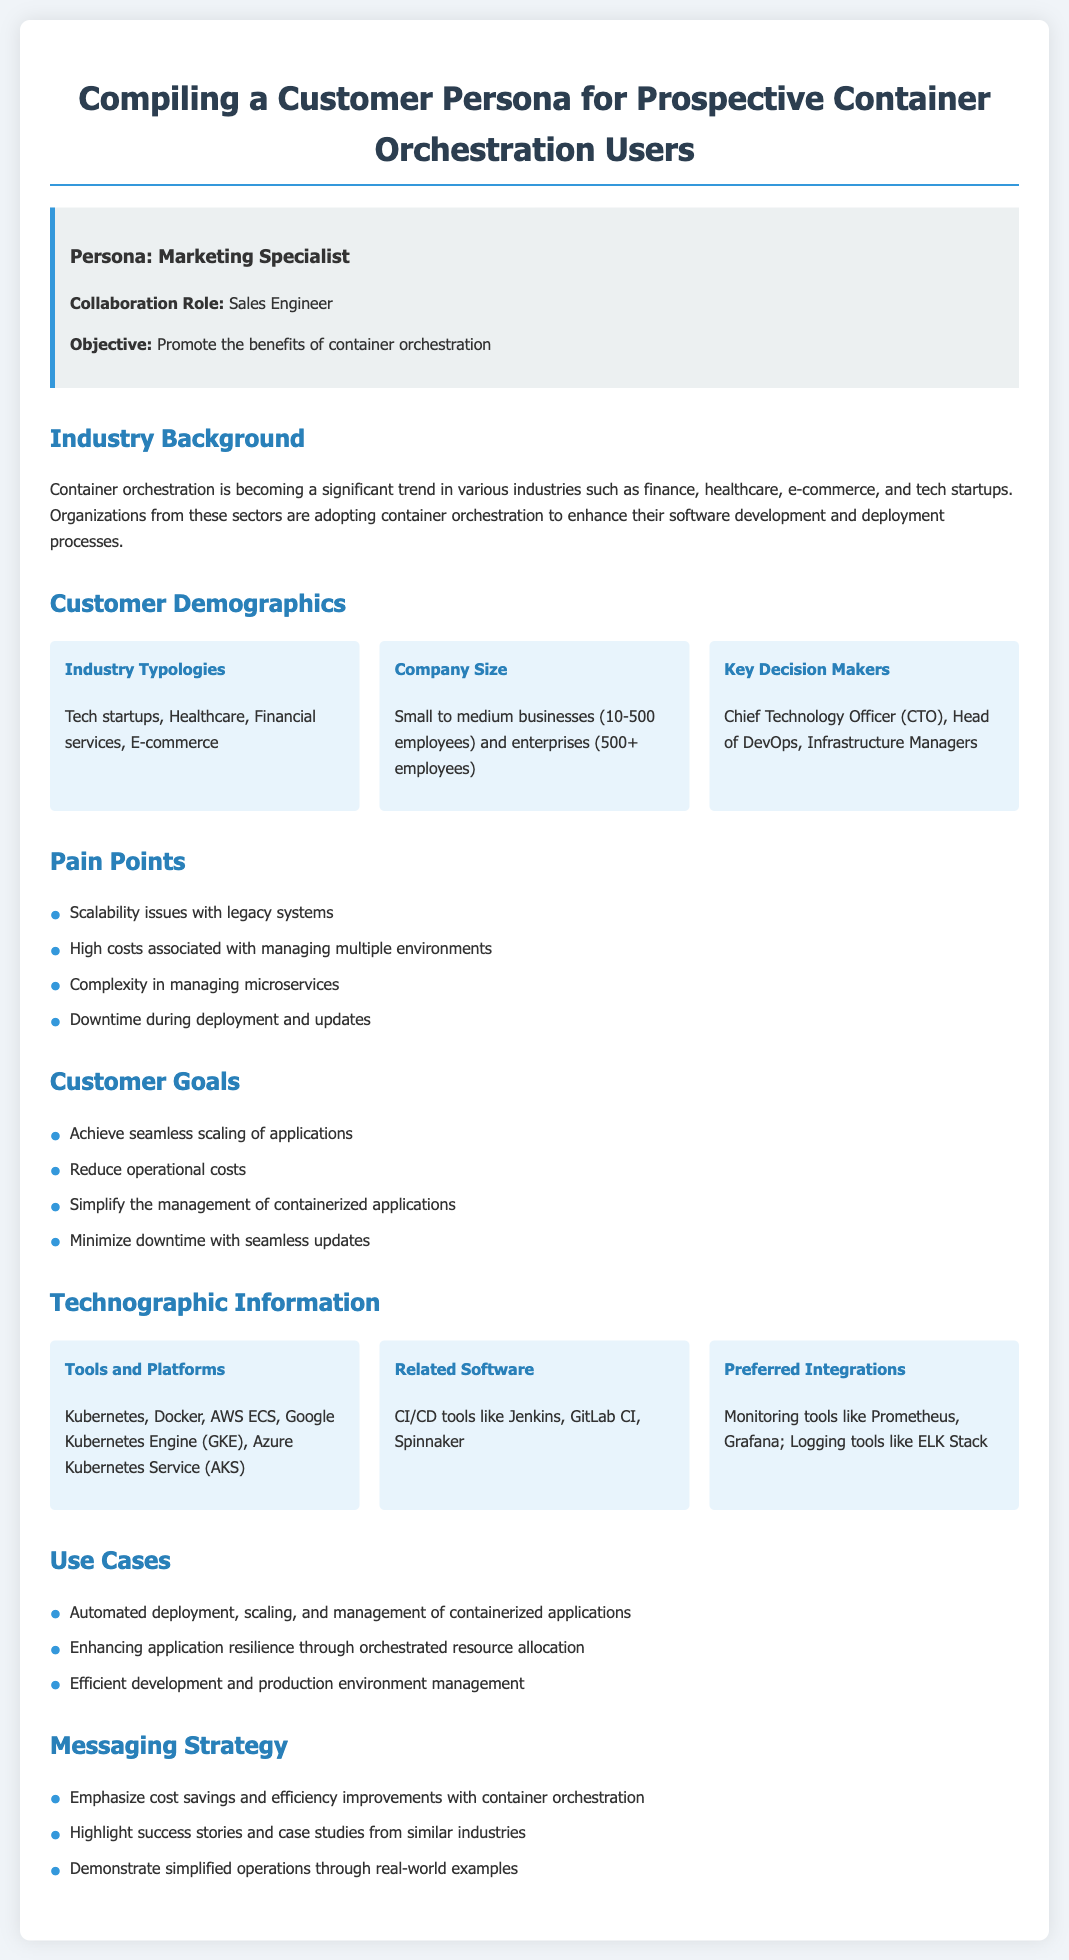What is the persona type? The document identifies the persona as a "Marketing Specialist".
Answer: Marketing Specialist Who does the Marketing Specialist collaborate with? It specifies that the collaboration role of the Marketing Specialist is with a "Sales Engineer".
Answer: Sales Engineer What is one key demographic of prospective users? The document lists "Small to medium businesses (10-500 employees)" and "enterprises (500+ employees)" as key demographics.
Answer: Small to medium businesses What is a pain point mentioned for prospective users? The document lists several pain points, one being "Scalability issues with legacy systems".
Answer: Scalability issues with legacy systems Name a goal of the prospective container orchestration users. One of the goals listed is "Achieve seamless scaling of applications".
Answer: Achieve seamless scaling of applications What platform is mentioned as a preferred tool in the document? The document mentions "Kubernetes" as one of the tools.
Answer: Kubernetes Which decision makers are identified? The document identifies "Chief Technology Officer (CTO)" as one of the key decision makers.
Answer: Chief Technology Officer (CTO) What is one use case for container orchestration mentioned? One use case mentioned is "Automated deployment, scaling, and management of containerized applications".
Answer: Automated deployment, scaling, and management of containerized applications What messaging strategy is emphasized in the document? The document emphasizes "cost savings and efficiency improvements" as part of the messaging strategy.
Answer: cost savings and efficiency improvements 